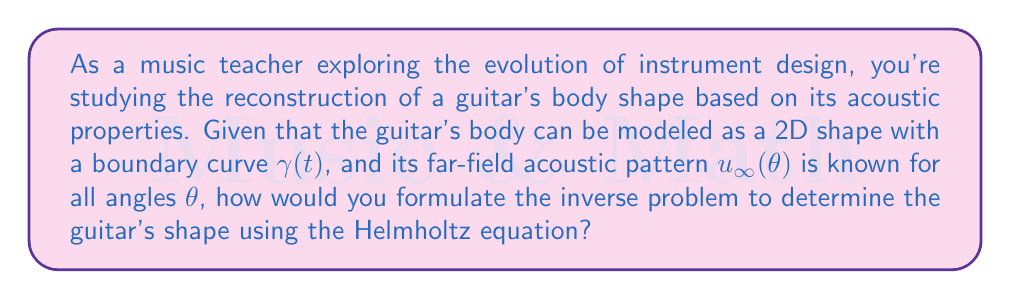Can you solve this math problem? To formulate this inverse problem, we need to follow these steps:

1. Define the forward problem:
   The acoustic field $u(x)$ satisfies the Helmholtz equation:
   $$\Delta u + k^2u = 0 \quad \text{in} \quad \mathbb{R}^2 \setminus \overline{D}$$
   where $D$ is the domain enclosed by the curve $\gamma(t)$, and $k$ is the wavenumber.

2. Set the boundary condition:
   On the boundary $\gamma(t)$, we have the Dirichlet condition:
   $$u = 0 \quad \text{on} \quad \gamma(t)$$

3. Define the far-field pattern:
   The far-field pattern $u_\infty(\theta)$ is related to the solution $u(x)$ by:
   $$u(x) = \frac{e^{ik|x|}}{\sqrt{|x|}}\left(u_\infty(\theta) + O\left(\frac{1}{|x|}\right)\right)$$
   as $|x| \to \infty$, where $\theta = x/|x|$.

4. Formulate the inverse problem:
   Given the far-field pattern $u_\infty(\theta)$ for all angles $\theta$, determine the boundary curve $\gamma(t)$ of the guitar's body.

5. Apply an iterative method:
   Use a method like the Newton iteration to minimize the difference between the measured far-field pattern and the computed far-field pattern for an estimated shape.

This formulation allows us to reconstruct the guitar's shape by solving the inverse problem, which involves finding the boundary curve $\gamma(t)$ that produces the given far-field acoustic pattern $u_\infty(\theta)$.
Answer: Minimize $\|\mathcal{F}(\gamma) - u_\infty\|$, where $\mathcal{F}$ maps $\gamma$ to far-field pattern 